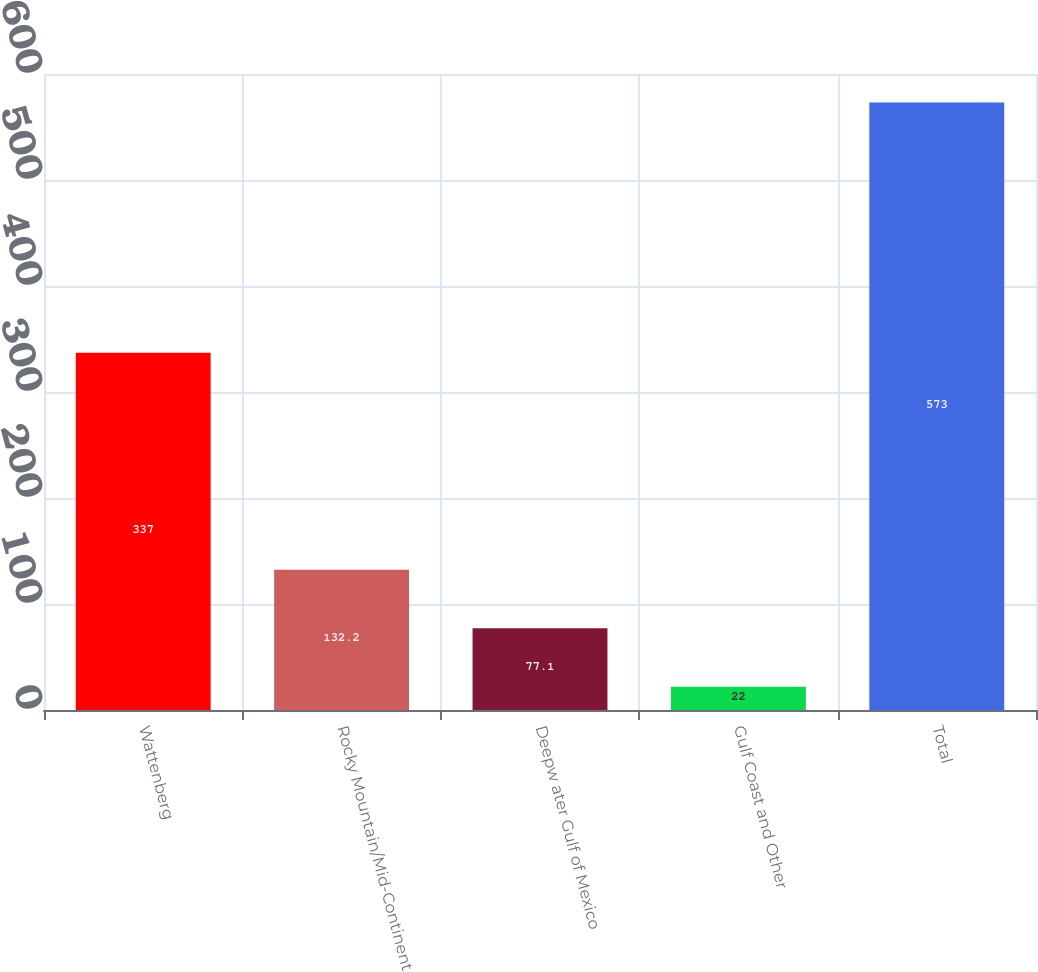Convert chart to OTSL. <chart><loc_0><loc_0><loc_500><loc_500><bar_chart><fcel>Wattenberg<fcel>Rocky Mountain/Mid-Continent<fcel>Deepw ater Gulf of Mexico<fcel>Gulf Coast and Other<fcel>Total<nl><fcel>337<fcel>132.2<fcel>77.1<fcel>22<fcel>573<nl></chart> 